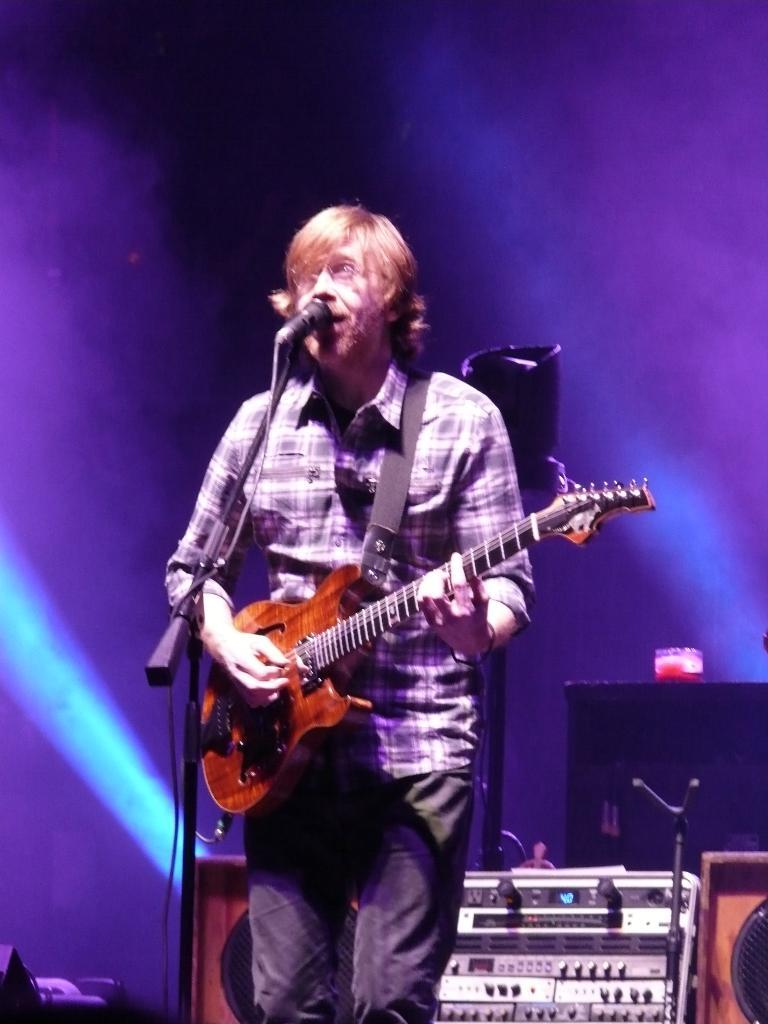What is the man in the image doing? The man is standing and singing in the image. What is the man holding in his hands? The man is holding a guitar in his hands. What is the man using to amplify his voice? There is a microphone in the image, which the man might be using to amplify his voice. What is the microphone attached to in the image? There is a microphone stand in the image, which the microphone is attached to. What can be seen in the background of the image? There are objects visible in the background of the image. What type of plastic shoes is the man wearing in the image? There is no mention of shoes in the image, so it is not possible to determine what type of shoes the man might be wearing. 